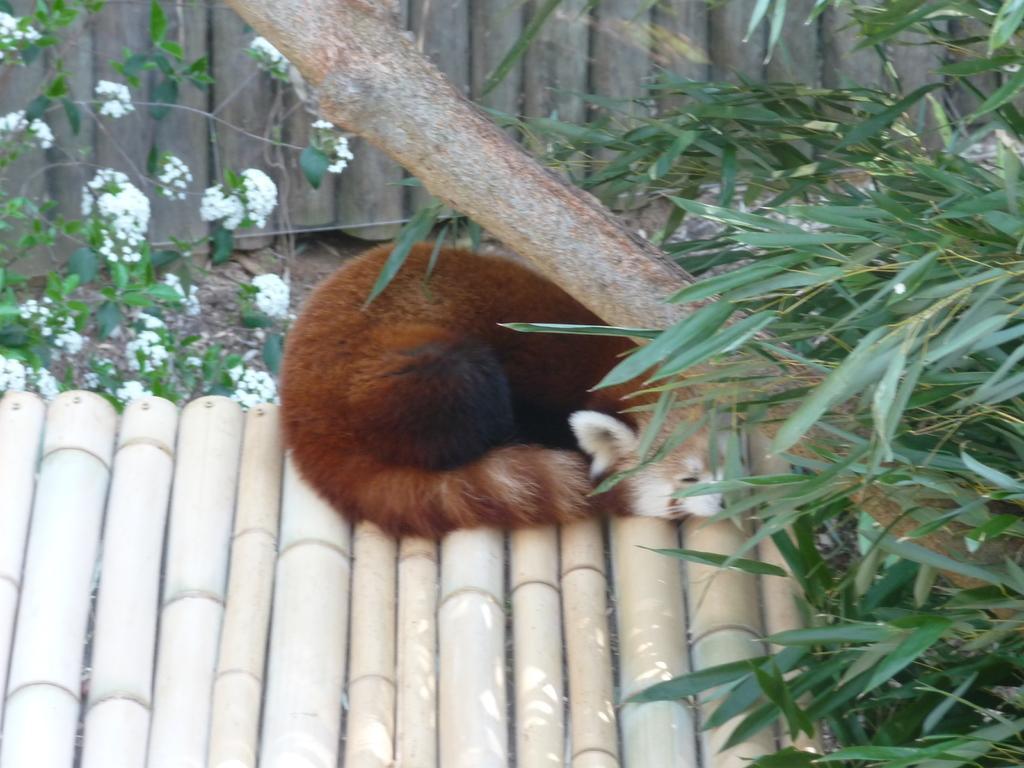How would you summarize this image in a sentence or two? In this image in the center there is one cat, and at the bottom there are some bamboo sticks. And in the background there are some wooden poles, plants, flowers and on the right side there are some plants and there is a branch of a tree. 